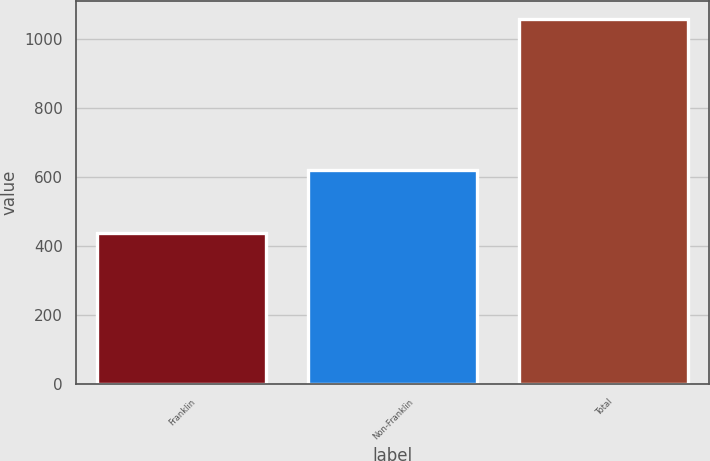Convert chart to OTSL. <chart><loc_0><loc_0><loc_500><loc_500><bar_chart><fcel>Franklin<fcel>Non-Franklin<fcel>Total<nl><fcel>438<fcel>619.5<fcel>1057.5<nl></chart> 